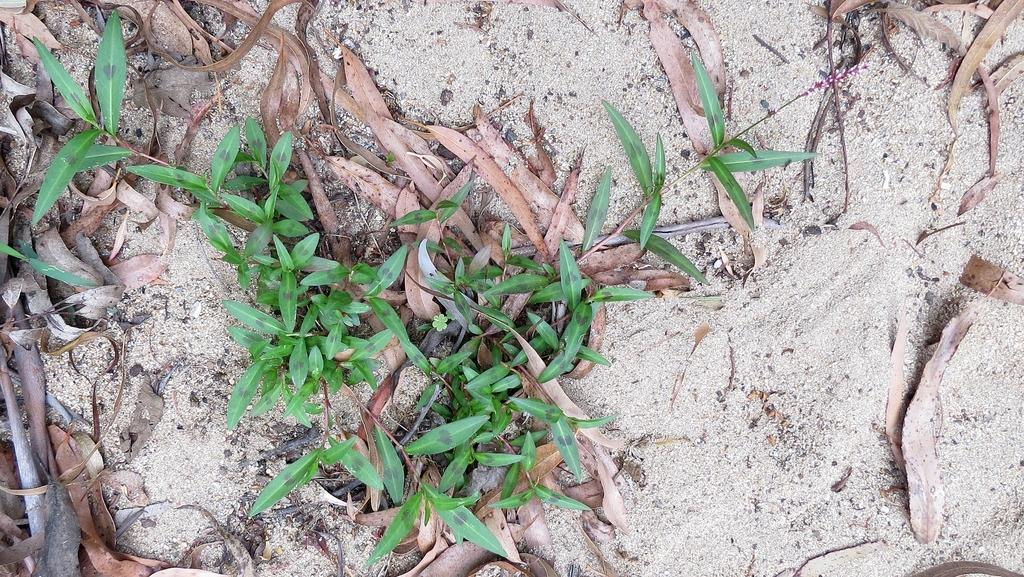What type of vegetation can be seen in the image? There are plants in the image. What is the condition of the leaves on the plants? Dried leaves are present in the image. What type of surface is the plants and dried leaves resting on? The plants and dried leaves are on sand. What type of corn can be seen growing on the moon in the image? There is no corn or moon present in the image; it features plants and dried leaves on sand. 